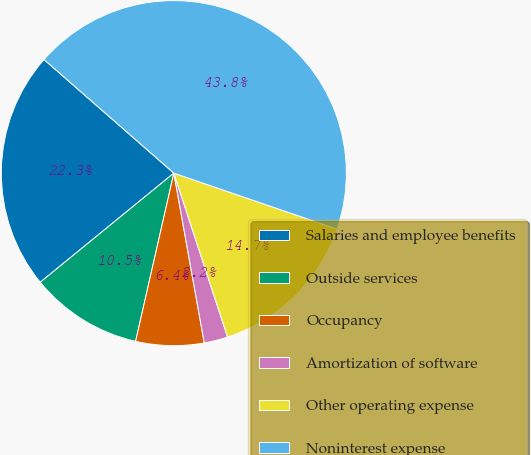<chart> <loc_0><loc_0><loc_500><loc_500><pie_chart><fcel>Salaries and employee benefits<fcel>Outside services<fcel>Occupancy<fcel>Amortization of software<fcel>Other operating expense<fcel>Noninterest expense<nl><fcel>22.34%<fcel>10.54%<fcel>6.38%<fcel>2.22%<fcel>14.7%<fcel>43.82%<nl></chart> 